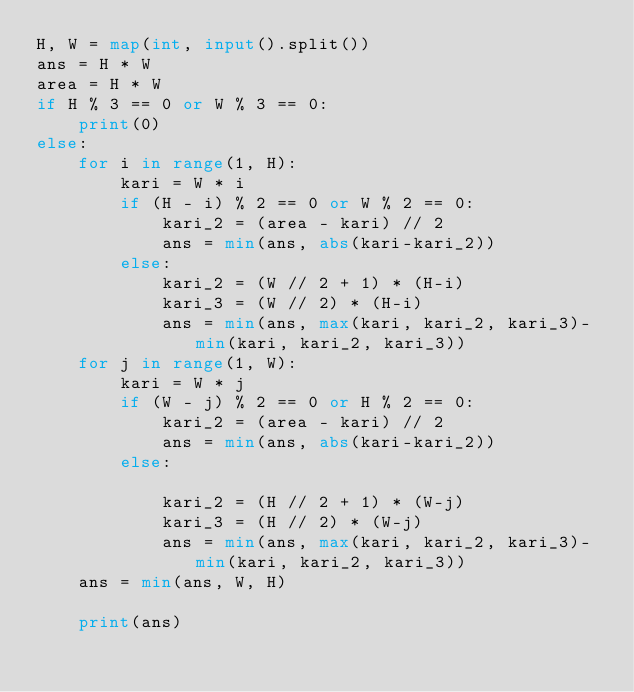Convert code to text. <code><loc_0><loc_0><loc_500><loc_500><_Python_>H, W = map(int, input().split())
ans = H * W
area = H * W
if H % 3 == 0 or W % 3 == 0:
    print(0)
else:
    for i in range(1, H):
        kari = W * i
        if (H - i) % 2 == 0 or W % 2 == 0:
            kari_2 = (area - kari) // 2
            ans = min(ans, abs(kari-kari_2))
        else:
            kari_2 = (W // 2 + 1) * (H-i)
            kari_3 = (W // 2) * (H-i)
            ans = min(ans, max(kari, kari_2, kari_3)-min(kari, kari_2, kari_3))
    for j in range(1, W):
        kari = W * j
        if (W - j) % 2 == 0 or H % 2 == 0:
            kari_2 = (area - kari) // 2
            ans = min(ans, abs(kari-kari_2))
        else:

            kari_2 = (H // 2 + 1) * (W-j)
            kari_3 = (H // 2) * (W-j)
            ans = min(ans, max(kari, kari_2, kari_3)-min(kari, kari_2, kari_3))
    ans = min(ans, W, H)

    print(ans)
</code> 